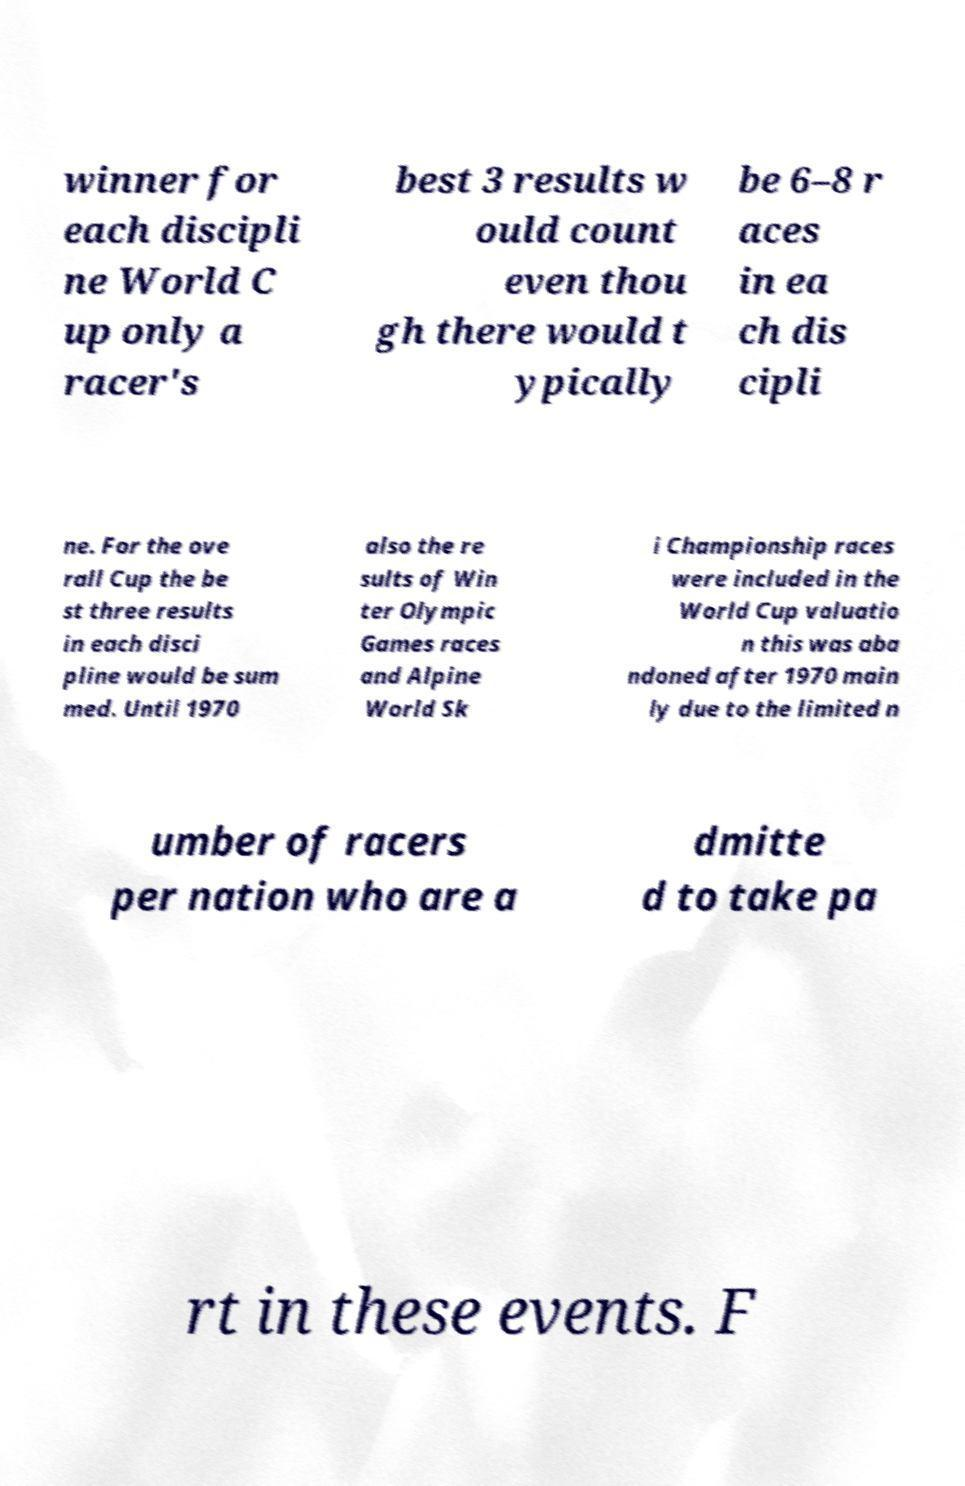Please read and relay the text visible in this image. What does it say? winner for each discipli ne World C up only a racer's best 3 results w ould count even thou gh there would t ypically be 6–8 r aces in ea ch dis cipli ne. For the ove rall Cup the be st three results in each disci pline would be sum med. Until 1970 also the re sults of Win ter Olympic Games races and Alpine World Sk i Championship races were included in the World Cup valuatio n this was aba ndoned after 1970 main ly due to the limited n umber of racers per nation who are a dmitte d to take pa rt in these events. F 